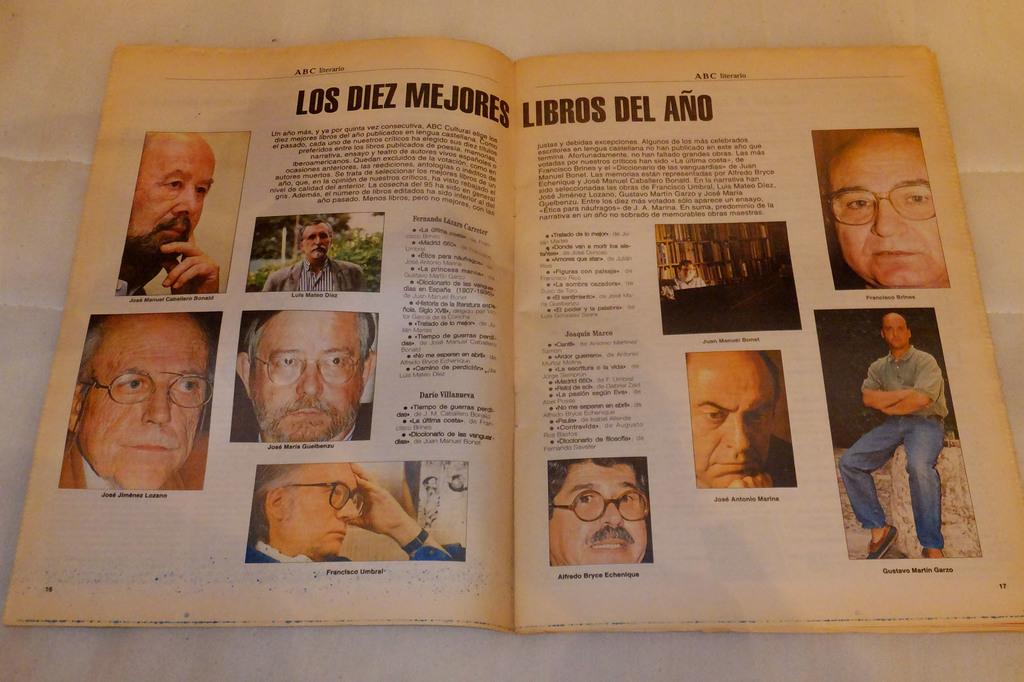What is the main object in the image? There is a book in the image. What type of content does the book have? The book contains pictures and text. Where is the book located in the image? The book is placed on a surface. What type of army is depicted in the book? There is no army depicted in the book, as it contains pictures and text about other subjects. How many cats are shown in the book? There are no cats shown in the book, as it contains pictures and text about other subjects. 